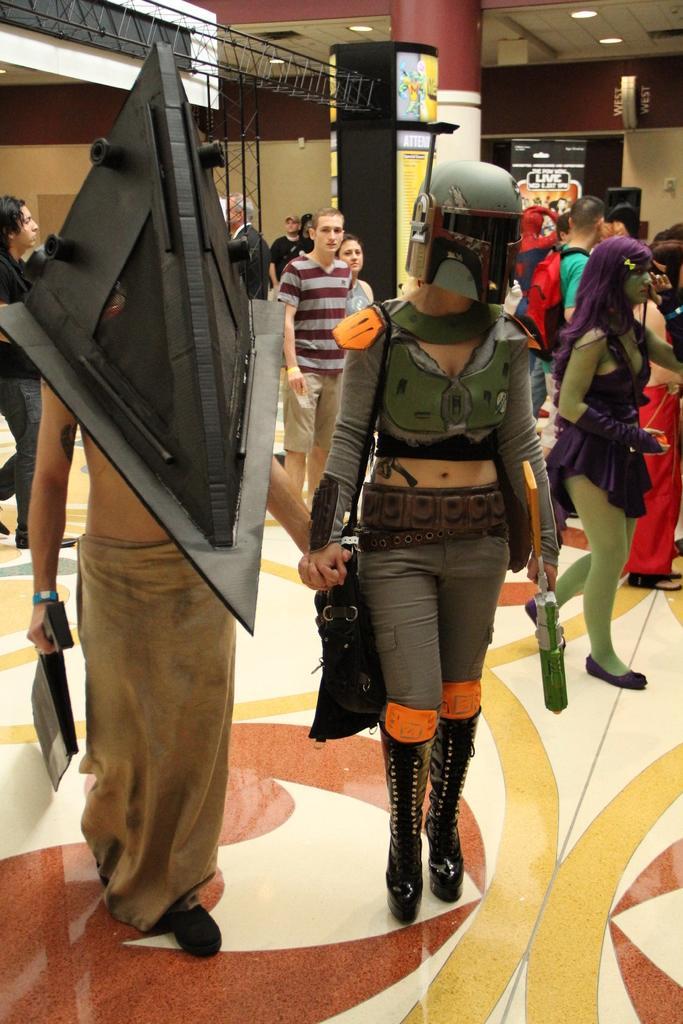How would you summarize this image in a sentence or two? In this image we can see a woman wearing the helmet and holding an object and standing on the floor. We can also see a person with an object. In the background we can see the people. We can also see the rods, pillar, wall, banner and also the ceiling with the ceiling lights. 